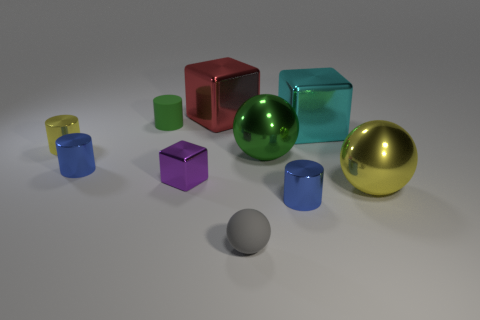Is there a tiny cylinder of the same color as the rubber ball? After reviewing the image, there are several cylinders present, but none of them match the color of the rubber ball exactly. The rubber ball appears to be a greenish hue, and while there are similar colors, there is no tiny cylinder that is an exact match in color. 